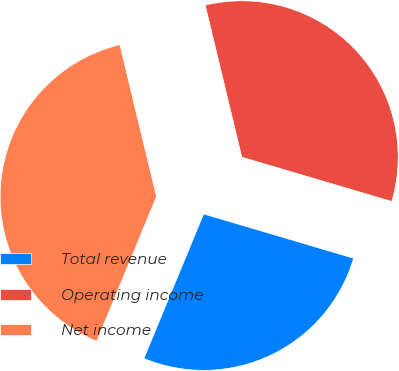<chart> <loc_0><loc_0><loc_500><loc_500><pie_chart><fcel>Total revenue<fcel>Operating income<fcel>Net income<nl><fcel>26.67%<fcel>33.33%<fcel>40.0%<nl></chart> 